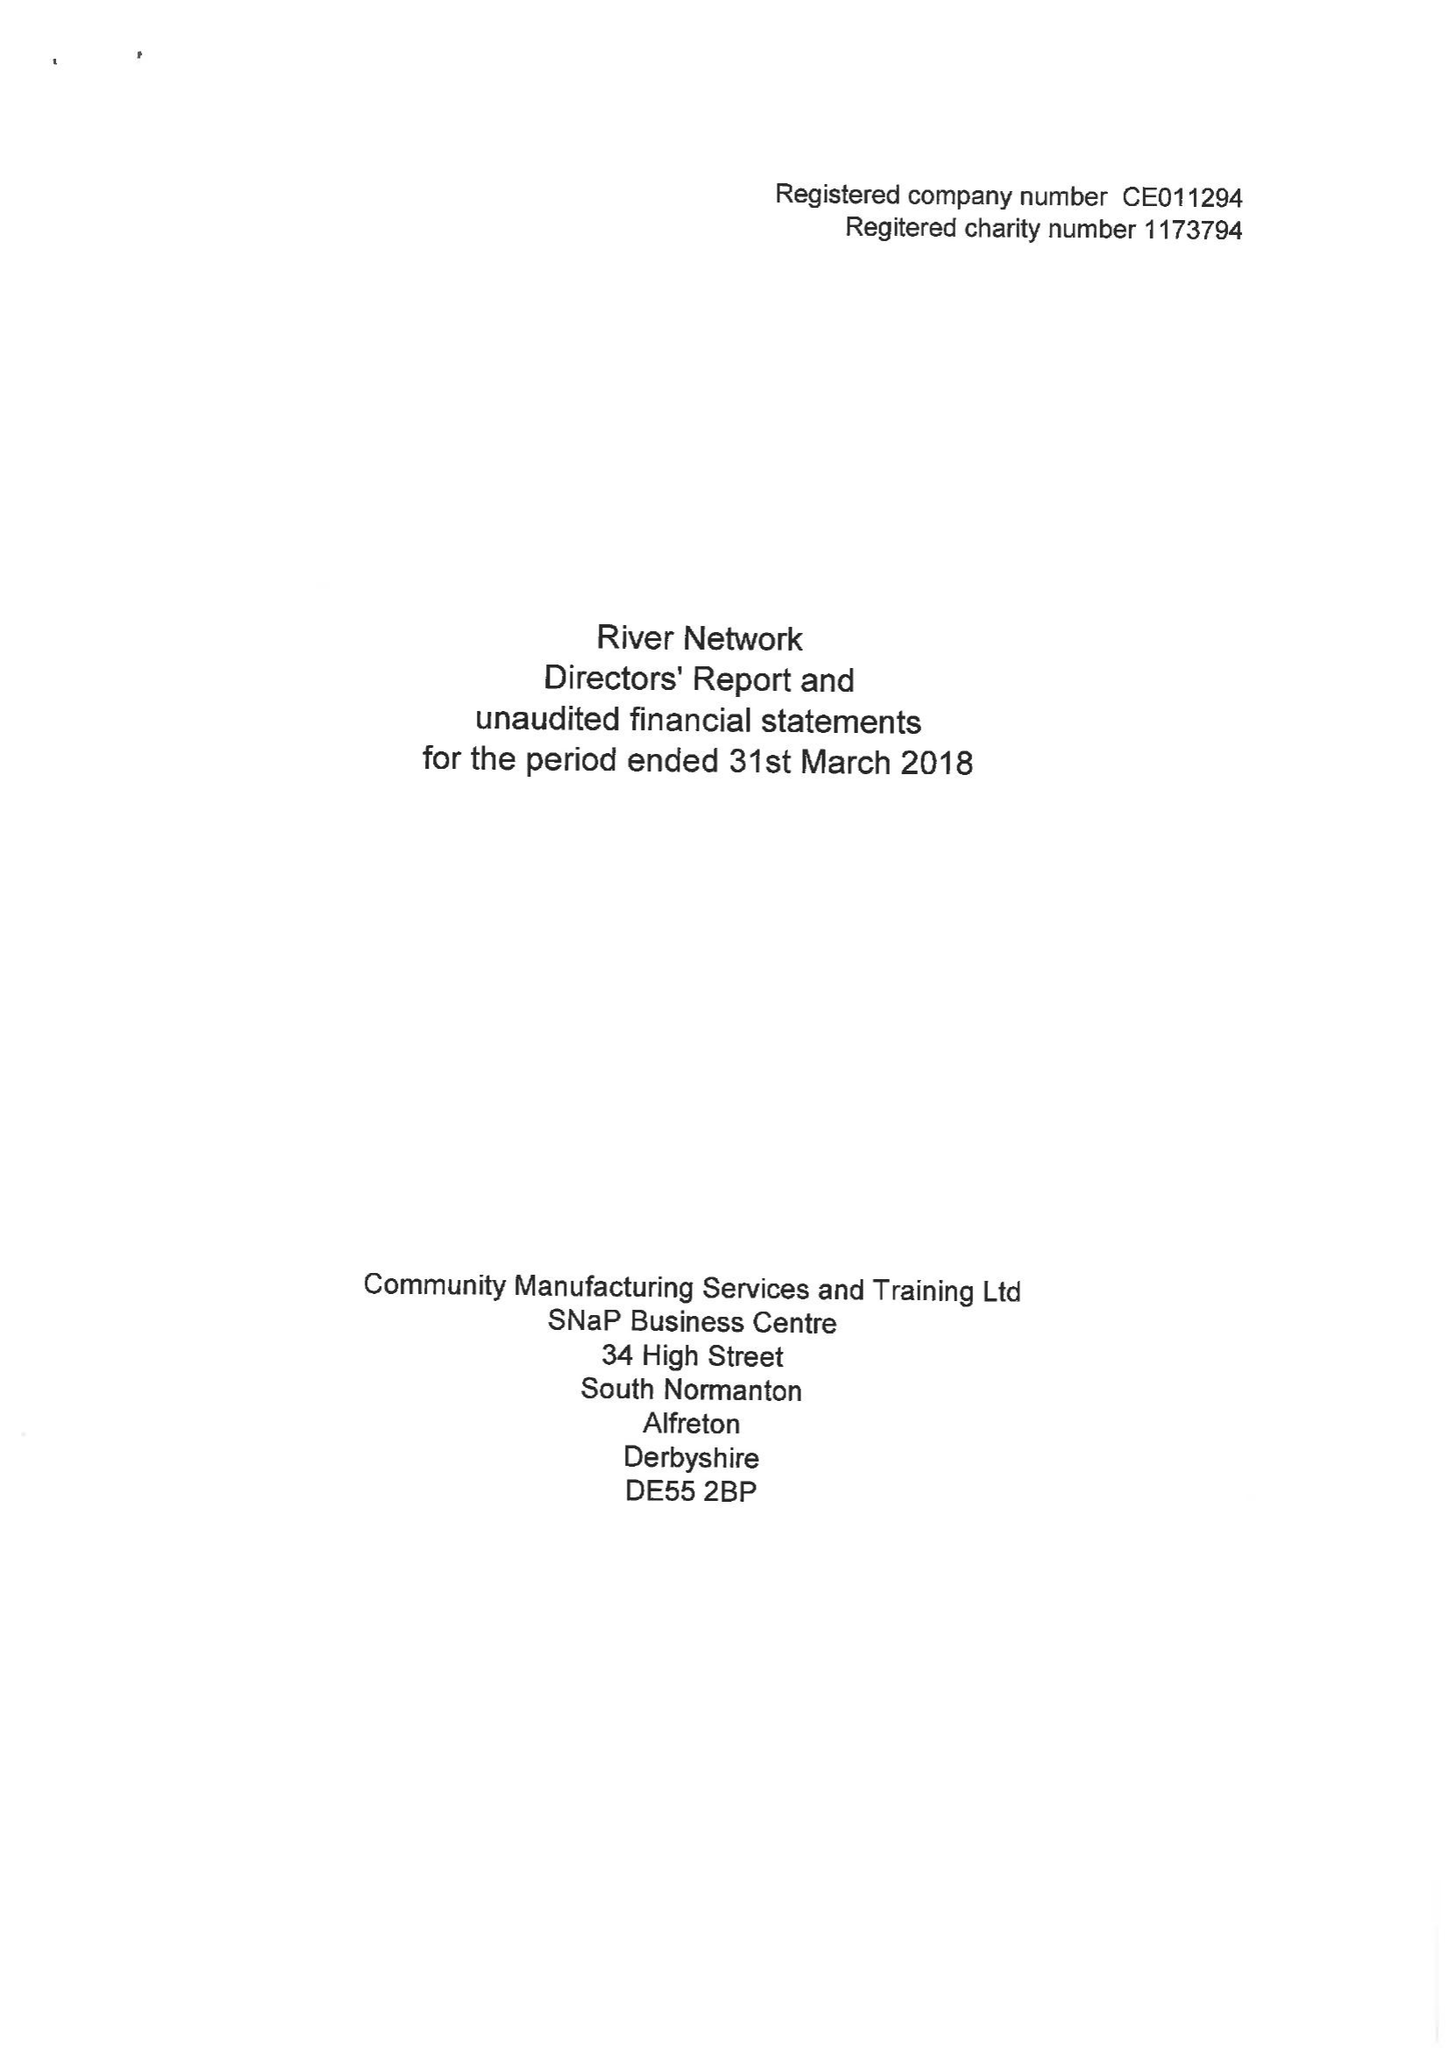What is the value for the spending_annually_in_british_pounds?
Answer the question using a single word or phrase. None 